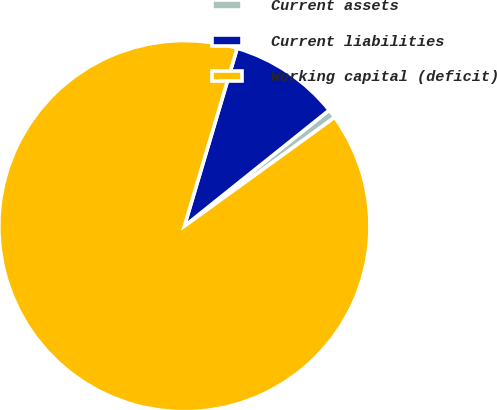<chart> <loc_0><loc_0><loc_500><loc_500><pie_chart><fcel>Current assets<fcel>Current liabilities<fcel>Working capital (deficit)<nl><fcel>0.78%<fcel>9.66%<fcel>89.56%<nl></chart> 